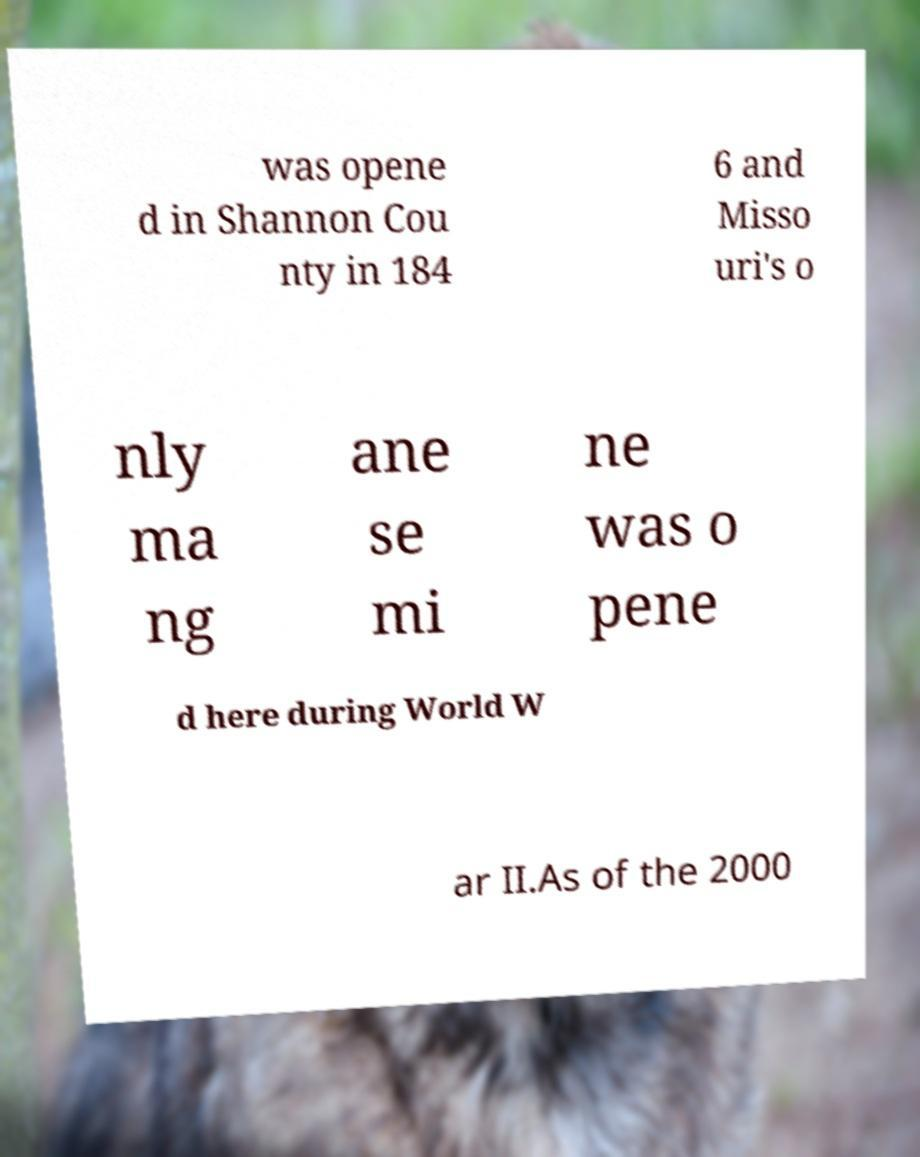Can you accurately transcribe the text from the provided image for me? was opene d in Shannon Cou nty in 184 6 and Misso uri's o nly ma ng ane se mi ne was o pene d here during World W ar II.As of the 2000 